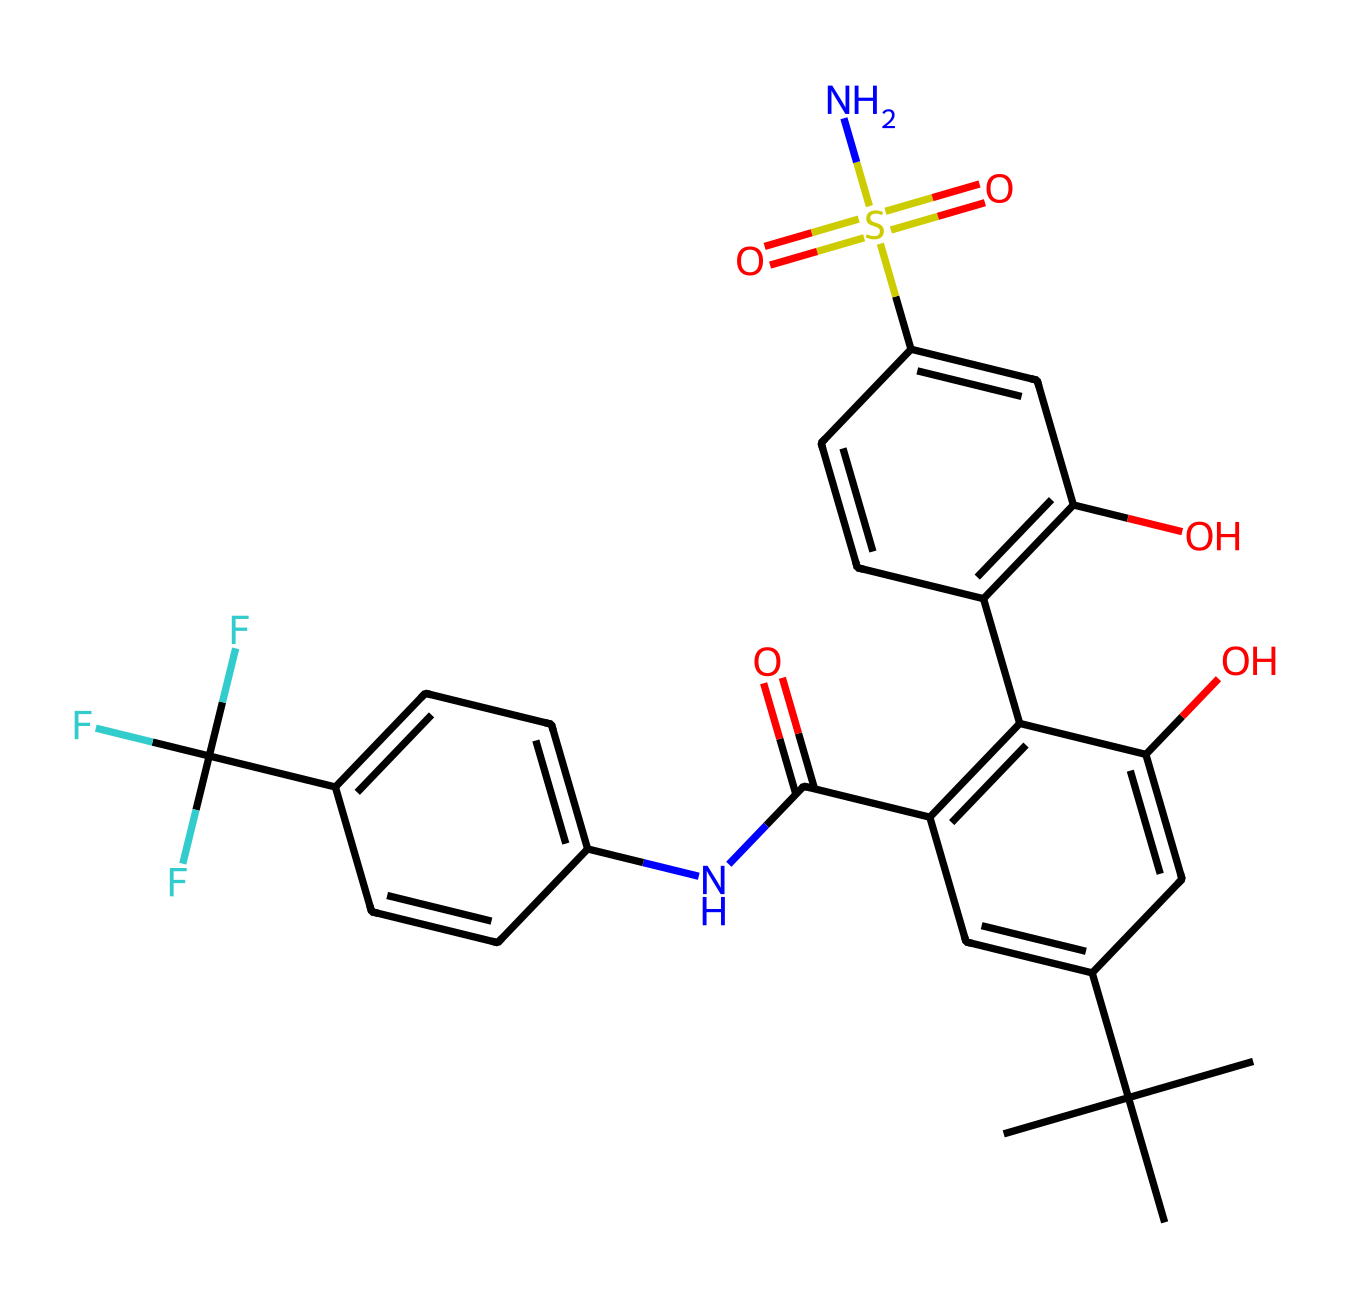What is the molecular formula of this compound? By analyzing the SMILES representation, we can identify the atoms present. Count the number of carbon (C), hydrogen (H), nitrogen (N), oxygen (O), and sulfur (S) atoms. The total count from the structure gives us the molecular formula C15H16F3N1O5S1.
Answer: C15H16F3N1O5S1 How many rings are present in this structure? In the SMILES representation, we can identify the ring structures by looking for numbers that indicate ring closures. There are two pairs of numbers indicating two distinct ring structures. Hence, there are two rings in this compound.
Answer: 2 What type of functional group is indicated by "S(=O)(=O)"? This representation shows a sulfur atom bonded to two oxygen atoms with double bonds (indicated by the parentheses). This signifies the presence of a sulfonyl group, which is characteristic of sulfonamides.
Answer: sulfonyl Which part of the molecule indicates it is an artificial sweetener? The presence of the amine group (–N) near the aromatic rings suggests that the molecule has modifications typical of artificial sweeteners, such as enhanced sweetness through structural complexity.
Answer: aromatic rings What is the significance of the "C(F)(F)F" part of the structure? This indicates the presence of fluorine atoms bonded to a carbon atom, which is characteristic of compounds designed to increase sweetness. The fluorine atoms impart unique properties, such as enhanced stability and sweet taste.
Answer: fluorine What does the "C(=O)N" segment suggest about the structure? This part indicates the presence of an amide group where a carbon is double-bonded to oxygen and single-bonded to nitrogen. This suggests that the compound can interact with biological systems in a way that modifies taste perception.
Answer: amide group How many different elements are present in this compound? By examining the SMILES, we can identify elements: carbon (C), hydrogen (H), nitrogen (N), oxygen (O), sulfur (S), and fluorine (F). This totals six different elements.
Answer: 6 